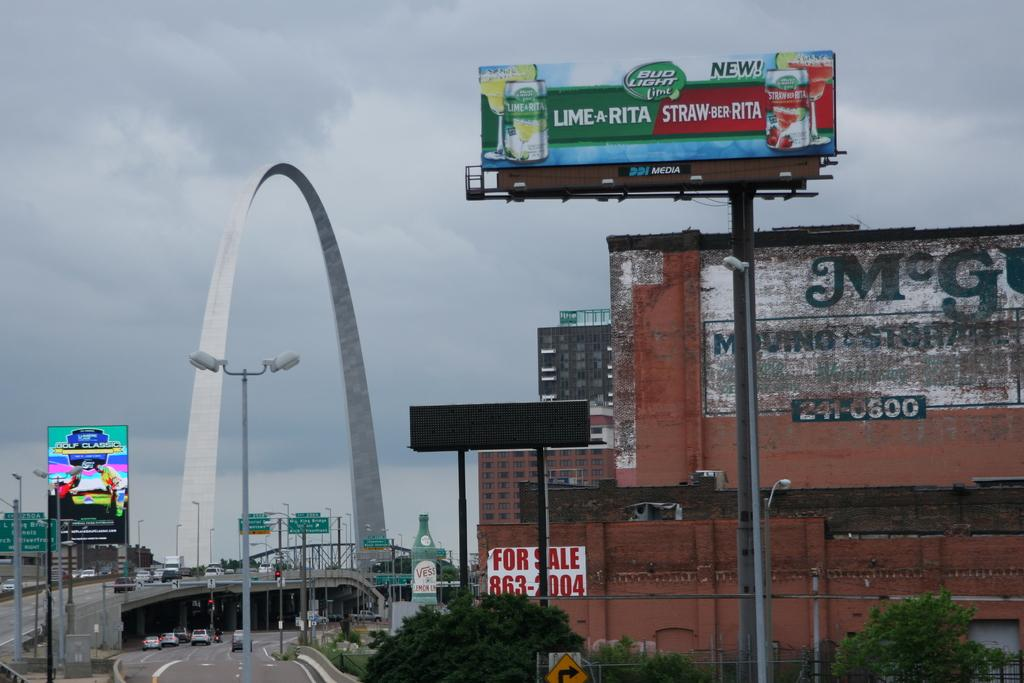<image>
Provide a brief description of the given image. A billboard near the arch advertises Bud Light. 